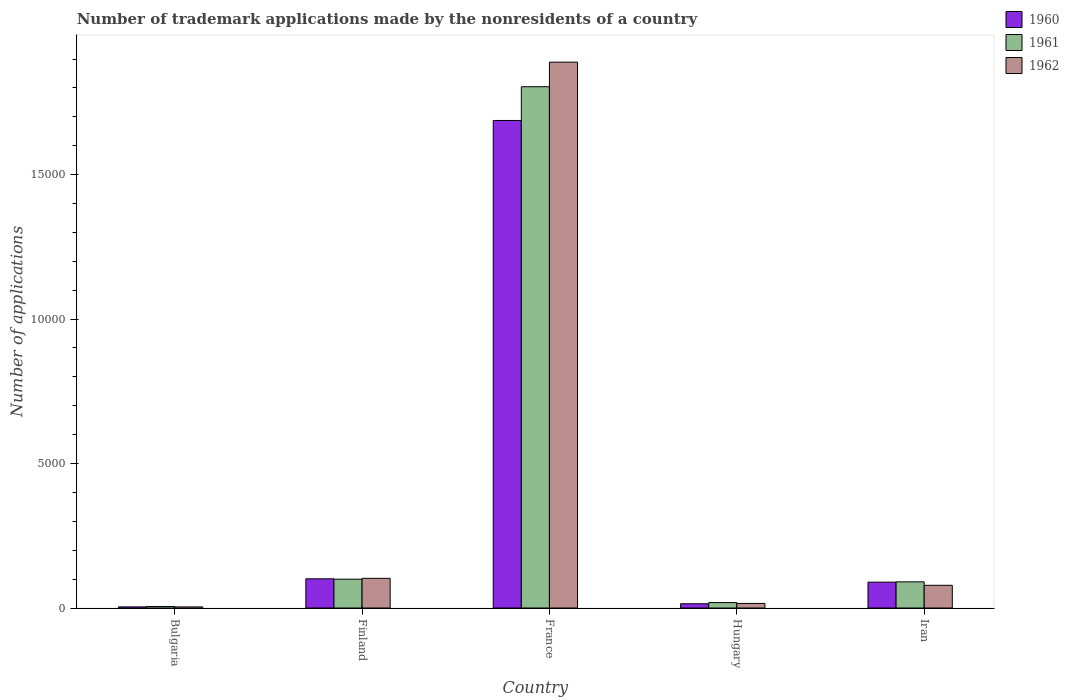How many different coloured bars are there?
Offer a terse response. 3. How many bars are there on the 2nd tick from the left?
Give a very brief answer. 3. What is the number of trademark applications made by the nonresidents in 1961 in France?
Offer a terse response. 1.80e+04. Across all countries, what is the maximum number of trademark applications made by the nonresidents in 1962?
Your answer should be compact. 1.89e+04. In which country was the number of trademark applications made by the nonresidents in 1960 minimum?
Ensure brevity in your answer.  Bulgaria. What is the total number of trademark applications made by the nonresidents in 1960 in the graph?
Make the answer very short. 1.90e+04. What is the difference between the number of trademark applications made by the nonresidents in 1961 in Finland and that in France?
Ensure brevity in your answer.  -1.70e+04. What is the difference between the number of trademark applications made by the nonresidents in 1960 in France and the number of trademark applications made by the nonresidents in 1961 in Finland?
Your response must be concise. 1.59e+04. What is the average number of trademark applications made by the nonresidents in 1961 per country?
Make the answer very short. 4036.8. In how many countries, is the number of trademark applications made by the nonresidents in 1960 greater than 18000?
Provide a short and direct response. 0. What is the ratio of the number of trademark applications made by the nonresidents in 1960 in Bulgaria to that in Finland?
Give a very brief answer. 0.04. What is the difference between the highest and the second highest number of trademark applications made by the nonresidents in 1962?
Give a very brief answer. -241. What is the difference between the highest and the lowest number of trademark applications made by the nonresidents in 1961?
Offer a terse response. 1.80e+04. In how many countries, is the number of trademark applications made by the nonresidents in 1960 greater than the average number of trademark applications made by the nonresidents in 1960 taken over all countries?
Your response must be concise. 1. What does the 3rd bar from the left in Hungary represents?
Your answer should be very brief. 1962. What does the 1st bar from the right in Bulgaria represents?
Provide a short and direct response. 1962. Is it the case that in every country, the sum of the number of trademark applications made by the nonresidents in 1960 and number of trademark applications made by the nonresidents in 1961 is greater than the number of trademark applications made by the nonresidents in 1962?
Your answer should be very brief. Yes. Are all the bars in the graph horizontal?
Your answer should be very brief. No. How many countries are there in the graph?
Your response must be concise. 5. What is the difference between two consecutive major ticks on the Y-axis?
Your response must be concise. 5000. How are the legend labels stacked?
Keep it short and to the point. Vertical. What is the title of the graph?
Provide a short and direct response. Number of trademark applications made by the nonresidents of a country. What is the label or title of the X-axis?
Offer a very short reply. Country. What is the label or title of the Y-axis?
Your response must be concise. Number of applications. What is the Number of applications in 1960 in Bulgaria?
Your response must be concise. 39. What is the Number of applications of 1960 in Finland?
Your answer should be very brief. 1011. What is the Number of applications in 1961 in Finland?
Give a very brief answer. 998. What is the Number of applications in 1962 in Finland?
Make the answer very short. 1027. What is the Number of applications in 1960 in France?
Offer a terse response. 1.69e+04. What is the Number of applications of 1961 in France?
Your answer should be compact. 1.80e+04. What is the Number of applications in 1962 in France?
Offer a terse response. 1.89e+04. What is the Number of applications of 1960 in Hungary?
Your answer should be compact. 147. What is the Number of applications in 1961 in Hungary?
Provide a succinct answer. 188. What is the Number of applications of 1962 in Hungary?
Your answer should be very brief. 158. What is the Number of applications in 1960 in Iran?
Your response must be concise. 895. What is the Number of applications of 1961 in Iran?
Offer a very short reply. 905. What is the Number of applications in 1962 in Iran?
Your answer should be compact. 786. Across all countries, what is the maximum Number of applications of 1960?
Your response must be concise. 1.69e+04. Across all countries, what is the maximum Number of applications of 1961?
Offer a terse response. 1.80e+04. Across all countries, what is the maximum Number of applications in 1962?
Ensure brevity in your answer.  1.89e+04. Across all countries, what is the minimum Number of applications in 1960?
Make the answer very short. 39. Across all countries, what is the minimum Number of applications of 1961?
Offer a terse response. 51. Across all countries, what is the minimum Number of applications in 1962?
Your answer should be compact. 38. What is the total Number of applications in 1960 in the graph?
Make the answer very short. 1.90e+04. What is the total Number of applications in 1961 in the graph?
Offer a very short reply. 2.02e+04. What is the total Number of applications in 1962 in the graph?
Offer a terse response. 2.09e+04. What is the difference between the Number of applications in 1960 in Bulgaria and that in Finland?
Give a very brief answer. -972. What is the difference between the Number of applications of 1961 in Bulgaria and that in Finland?
Provide a succinct answer. -947. What is the difference between the Number of applications of 1962 in Bulgaria and that in Finland?
Offer a terse response. -989. What is the difference between the Number of applications of 1960 in Bulgaria and that in France?
Give a very brief answer. -1.68e+04. What is the difference between the Number of applications of 1961 in Bulgaria and that in France?
Offer a very short reply. -1.80e+04. What is the difference between the Number of applications of 1962 in Bulgaria and that in France?
Keep it short and to the point. -1.89e+04. What is the difference between the Number of applications of 1960 in Bulgaria and that in Hungary?
Your response must be concise. -108. What is the difference between the Number of applications in 1961 in Bulgaria and that in Hungary?
Provide a succinct answer. -137. What is the difference between the Number of applications in 1962 in Bulgaria and that in Hungary?
Offer a very short reply. -120. What is the difference between the Number of applications in 1960 in Bulgaria and that in Iran?
Provide a succinct answer. -856. What is the difference between the Number of applications in 1961 in Bulgaria and that in Iran?
Offer a very short reply. -854. What is the difference between the Number of applications of 1962 in Bulgaria and that in Iran?
Your answer should be compact. -748. What is the difference between the Number of applications in 1960 in Finland and that in France?
Give a very brief answer. -1.59e+04. What is the difference between the Number of applications of 1961 in Finland and that in France?
Offer a terse response. -1.70e+04. What is the difference between the Number of applications in 1962 in Finland and that in France?
Provide a succinct answer. -1.79e+04. What is the difference between the Number of applications in 1960 in Finland and that in Hungary?
Keep it short and to the point. 864. What is the difference between the Number of applications in 1961 in Finland and that in Hungary?
Ensure brevity in your answer.  810. What is the difference between the Number of applications of 1962 in Finland and that in Hungary?
Offer a terse response. 869. What is the difference between the Number of applications in 1960 in Finland and that in Iran?
Give a very brief answer. 116. What is the difference between the Number of applications of 1961 in Finland and that in Iran?
Make the answer very short. 93. What is the difference between the Number of applications of 1962 in Finland and that in Iran?
Your response must be concise. 241. What is the difference between the Number of applications in 1960 in France and that in Hungary?
Provide a short and direct response. 1.67e+04. What is the difference between the Number of applications in 1961 in France and that in Hungary?
Offer a very short reply. 1.79e+04. What is the difference between the Number of applications in 1962 in France and that in Hungary?
Offer a terse response. 1.87e+04. What is the difference between the Number of applications in 1960 in France and that in Iran?
Give a very brief answer. 1.60e+04. What is the difference between the Number of applications of 1961 in France and that in Iran?
Make the answer very short. 1.71e+04. What is the difference between the Number of applications of 1962 in France and that in Iran?
Give a very brief answer. 1.81e+04. What is the difference between the Number of applications in 1960 in Hungary and that in Iran?
Offer a very short reply. -748. What is the difference between the Number of applications in 1961 in Hungary and that in Iran?
Provide a succinct answer. -717. What is the difference between the Number of applications of 1962 in Hungary and that in Iran?
Keep it short and to the point. -628. What is the difference between the Number of applications in 1960 in Bulgaria and the Number of applications in 1961 in Finland?
Provide a succinct answer. -959. What is the difference between the Number of applications in 1960 in Bulgaria and the Number of applications in 1962 in Finland?
Offer a very short reply. -988. What is the difference between the Number of applications of 1961 in Bulgaria and the Number of applications of 1962 in Finland?
Give a very brief answer. -976. What is the difference between the Number of applications of 1960 in Bulgaria and the Number of applications of 1961 in France?
Your response must be concise. -1.80e+04. What is the difference between the Number of applications of 1960 in Bulgaria and the Number of applications of 1962 in France?
Your answer should be compact. -1.89e+04. What is the difference between the Number of applications in 1961 in Bulgaria and the Number of applications in 1962 in France?
Provide a succinct answer. -1.88e+04. What is the difference between the Number of applications in 1960 in Bulgaria and the Number of applications in 1961 in Hungary?
Ensure brevity in your answer.  -149. What is the difference between the Number of applications of 1960 in Bulgaria and the Number of applications of 1962 in Hungary?
Offer a very short reply. -119. What is the difference between the Number of applications of 1961 in Bulgaria and the Number of applications of 1962 in Hungary?
Your answer should be compact. -107. What is the difference between the Number of applications in 1960 in Bulgaria and the Number of applications in 1961 in Iran?
Ensure brevity in your answer.  -866. What is the difference between the Number of applications of 1960 in Bulgaria and the Number of applications of 1962 in Iran?
Provide a short and direct response. -747. What is the difference between the Number of applications in 1961 in Bulgaria and the Number of applications in 1962 in Iran?
Your response must be concise. -735. What is the difference between the Number of applications in 1960 in Finland and the Number of applications in 1961 in France?
Give a very brief answer. -1.70e+04. What is the difference between the Number of applications in 1960 in Finland and the Number of applications in 1962 in France?
Make the answer very short. -1.79e+04. What is the difference between the Number of applications of 1961 in Finland and the Number of applications of 1962 in France?
Your answer should be very brief. -1.79e+04. What is the difference between the Number of applications in 1960 in Finland and the Number of applications in 1961 in Hungary?
Your answer should be very brief. 823. What is the difference between the Number of applications of 1960 in Finland and the Number of applications of 1962 in Hungary?
Your answer should be compact. 853. What is the difference between the Number of applications in 1961 in Finland and the Number of applications in 1962 in Hungary?
Offer a terse response. 840. What is the difference between the Number of applications of 1960 in Finland and the Number of applications of 1961 in Iran?
Provide a succinct answer. 106. What is the difference between the Number of applications of 1960 in Finland and the Number of applications of 1962 in Iran?
Provide a short and direct response. 225. What is the difference between the Number of applications of 1961 in Finland and the Number of applications of 1962 in Iran?
Your answer should be compact. 212. What is the difference between the Number of applications in 1960 in France and the Number of applications in 1961 in Hungary?
Provide a short and direct response. 1.67e+04. What is the difference between the Number of applications of 1960 in France and the Number of applications of 1962 in Hungary?
Provide a short and direct response. 1.67e+04. What is the difference between the Number of applications of 1961 in France and the Number of applications of 1962 in Hungary?
Ensure brevity in your answer.  1.79e+04. What is the difference between the Number of applications of 1960 in France and the Number of applications of 1961 in Iran?
Provide a short and direct response. 1.60e+04. What is the difference between the Number of applications in 1960 in France and the Number of applications in 1962 in Iran?
Your response must be concise. 1.61e+04. What is the difference between the Number of applications of 1961 in France and the Number of applications of 1962 in Iran?
Provide a short and direct response. 1.73e+04. What is the difference between the Number of applications of 1960 in Hungary and the Number of applications of 1961 in Iran?
Provide a short and direct response. -758. What is the difference between the Number of applications of 1960 in Hungary and the Number of applications of 1962 in Iran?
Make the answer very short. -639. What is the difference between the Number of applications in 1961 in Hungary and the Number of applications in 1962 in Iran?
Keep it short and to the point. -598. What is the average Number of applications of 1960 per country?
Give a very brief answer. 3793.2. What is the average Number of applications in 1961 per country?
Offer a terse response. 4036.8. What is the average Number of applications of 1962 per country?
Your answer should be compact. 4180.2. What is the difference between the Number of applications in 1960 and Number of applications in 1962 in Bulgaria?
Offer a terse response. 1. What is the difference between the Number of applications in 1961 and Number of applications in 1962 in Bulgaria?
Your answer should be compact. 13. What is the difference between the Number of applications in 1960 and Number of applications in 1962 in Finland?
Offer a very short reply. -16. What is the difference between the Number of applications in 1961 and Number of applications in 1962 in Finland?
Your response must be concise. -29. What is the difference between the Number of applications in 1960 and Number of applications in 1961 in France?
Keep it short and to the point. -1168. What is the difference between the Number of applications of 1960 and Number of applications of 1962 in France?
Offer a very short reply. -2018. What is the difference between the Number of applications in 1961 and Number of applications in 1962 in France?
Your response must be concise. -850. What is the difference between the Number of applications in 1960 and Number of applications in 1961 in Hungary?
Provide a short and direct response. -41. What is the difference between the Number of applications in 1961 and Number of applications in 1962 in Hungary?
Your answer should be very brief. 30. What is the difference between the Number of applications in 1960 and Number of applications in 1961 in Iran?
Your answer should be compact. -10. What is the difference between the Number of applications in 1960 and Number of applications in 1962 in Iran?
Your answer should be compact. 109. What is the difference between the Number of applications in 1961 and Number of applications in 1962 in Iran?
Make the answer very short. 119. What is the ratio of the Number of applications of 1960 in Bulgaria to that in Finland?
Your response must be concise. 0.04. What is the ratio of the Number of applications of 1961 in Bulgaria to that in Finland?
Offer a terse response. 0.05. What is the ratio of the Number of applications of 1962 in Bulgaria to that in Finland?
Offer a very short reply. 0.04. What is the ratio of the Number of applications of 1960 in Bulgaria to that in France?
Keep it short and to the point. 0. What is the ratio of the Number of applications of 1961 in Bulgaria to that in France?
Ensure brevity in your answer.  0. What is the ratio of the Number of applications of 1962 in Bulgaria to that in France?
Offer a very short reply. 0. What is the ratio of the Number of applications of 1960 in Bulgaria to that in Hungary?
Provide a short and direct response. 0.27. What is the ratio of the Number of applications of 1961 in Bulgaria to that in Hungary?
Ensure brevity in your answer.  0.27. What is the ratio of the Number of applications of 1962 in Bulgaria to that in Hungary?
Provide a succinct answer. 0.24. What is the ratio of the Number of applications of 1960 in Bulgaria to that in Iran?
Provide a short and direct response. 0.04. What is the ratio of the Number of applications of 1961 in Bulgaria to that in Iran?
Provide a short and direct response. 0.06. What is the ratio of the Number of applications in 1962 in Bulgaria to that in Iran?
Your answer should be very brief. 0.05. What is the ratio of the Number of applications of 1960 in Finland to that in France?
Give a very brief answer. 0.06. What is the ratio of the Number of applications in 1961 in Finland to that in France?
Your answer should be very brief. 0.06. What is the ratio of the Number of applications in 1962 in Finland to that in France?
Your answer should be very brief. 0.05. What is the ratio of the Number of applications in 1960 in Finland to that in Hungary?
Offer a very short reply. 6.88. What is the ratio of the Number of applications of 1961 in Finland to that in Hungary?
Your answer should be compact. 5.31. What is the ratio of the Number of applications in 1962 in Finland to that in Hungary?
Your response must be concise. 6.5. What is the ratio of the Number of applications of 1960 in Finland to that in Iran?
Give a very brief answer. 1.13. What is the ratio of the Number of applications in 1961 in Finland to that in Iran?
Make the answer very short. 1.1. What is the ratio of the Number of applications in 1962 in Finland to that in Iran?
Ensure brevity in your answer.  1.31. What is the ratio of the Number of applications of 1960 in France to that in Hungary?
Your answer should be compact. 114.79. What is the ratio of the Number of applications of 1961 in France to that in Hungary?
Make the answer very short. 95.97. What is the ratio of the Number of applications of 1962 in France to that in Hungary?
Give a very brief answer. 119.57. What is the ratio of the Number of applications in 1960 in France to that in Iran?
Keep it short and to the point. 18.85. What is the ratio of the Number of applications of 1961 in France to that in Iran?
Offer a terse response. 19.94. What is the ratio of the Number of applications of 1962 in France to that in Iran?
Make the answer very short. 24.04. What is the ratio of the Number of applications in 1960 in Hungary to that in Iran?
Your answer should be very brief. 0.16. What is the ratio of the Number of applications in 1961 in Hungary to that in Iran?
Keep it short and to the point. 0.21. What is the ratio of the Number of applications of 1962 in Hungary to that in Iran?
Your answer should be very brief. 0.2. What is the difference between the highest and the second highest Number of applications in 1960?
Keep it short and to the point. 1.59e+04. What is the difference between the highest and the second highest Number of applications of 1961?
Provide a succinct answer. 1.70e+04. What is the difference between the highest and the second highest Number of applications of 1962?
Ensure brevity in your answer.  1.79e+04. What is the difference between the highest and the lowest Number of applications in 1960?
Offer a very short reply. 1.68e+04. What is the difference between the highest and the lowest Number of applications in 1961?
Keep it short and to the point. 1.80e+04. What is the difference between the highest and the lowest Number of applications in 1962?
Provide a short and direct response. 1.89e+04. 